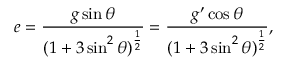<formula> <loc_0><loc_0><loc_500><loc_500>e = \frac { g \sin \theta } { ( 1 + 3 \sin ^ { 2 } \theta ) ^ { \frac { 1 } { 2 } } } = \frac { g ^ { \prime } \cos \theta } { ( 1 + 3 \sin ^ { 2 } \theta ) ^ { \frac { 1 } { 2 } } } ,</formula> 